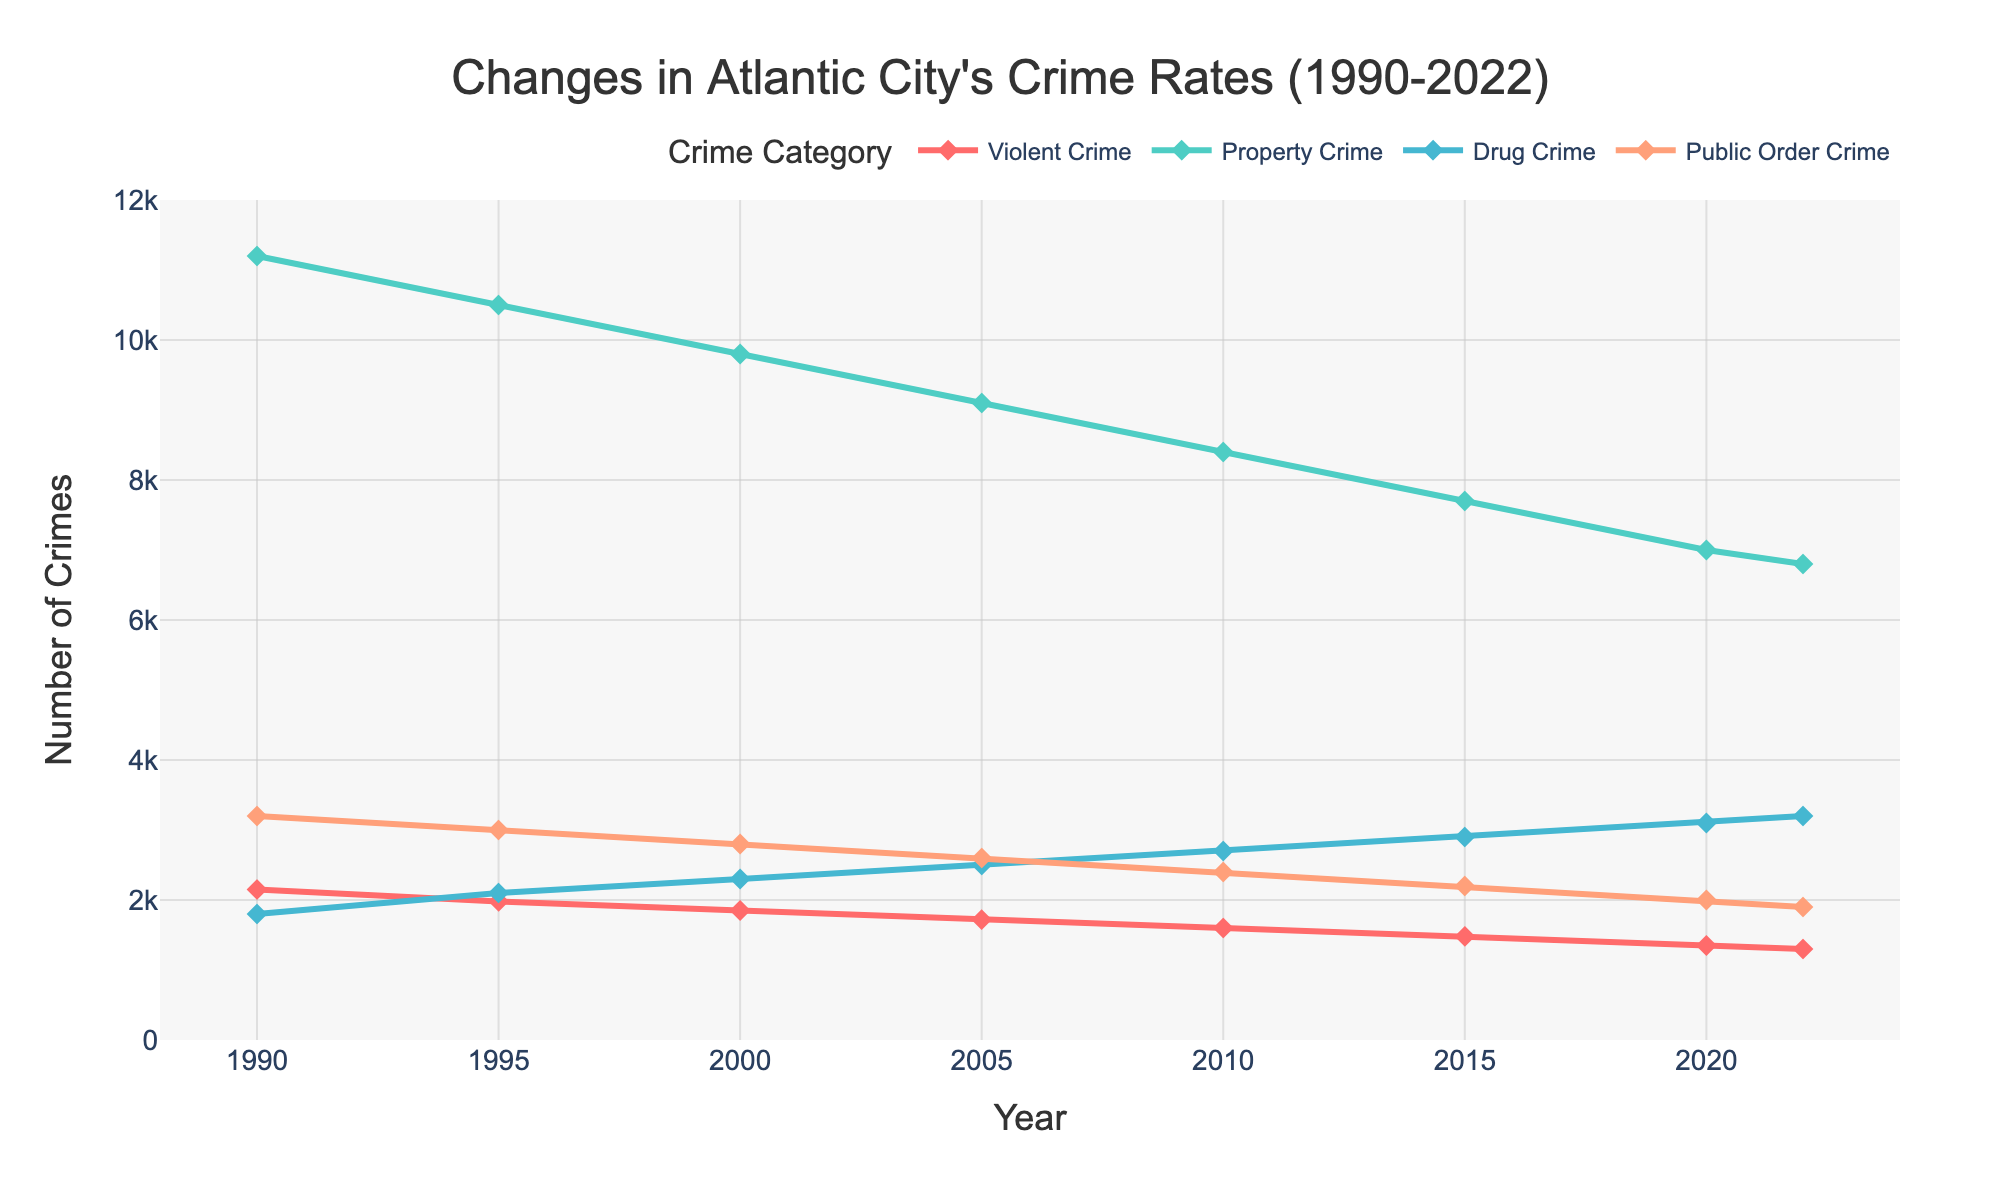How has the violent crime rate changed from 1990 to 2022? In 1990, the violent crime rate was 2150. By 2022, it decreased to 1300. The difference between these two values is 2150 - 1300 = 850, indicating a decrease in violent crime rate.
Answer: The violent crime rate decreased by 850 Which crime category had the largest reduction from 1990 to 2022? To determine the largest reduction, we subtract the crime rates in 2022 from those in 1990 for each category. Violent Crime: 2150 - 1300 = 850. Property Crime: 11200 - 6800 = 4400. Drug Crime: 1800 - 3200 = -1400 (an increase). Public Order Crime: 3200 - 1900 = 1300. Property Crime has the largest reduction: 4400.
Answer: Property Crime Comparing 1995 and 2022, which crime category saw the greatest decrease in absolute terms? Subtract 1995 figures from 2022 for each category. Violent Crime: 1980 - 1300 = 680. Property Crime: 10500 - 6800 = 3700. Drug Crime: 2100 - 3200 = -1100 (an increase). Public Order Crime: 3000 - 1900 = 1100. The greatest decrease is in Property Crime: 3700.
Answer: Property Crime In which year did Drug Crime surpass Public Order Crime for the first time? By observing the plot, we can see that Drug Crime surpasses Public Order Crime between 2005 and 2010. For exactitude, verify that in 2005 the Drug Crimes were 2500 and Public Order Crimes were 2600; in 2010, Drug Crimes were 2700 and Public Order Crimes were 2400. Thus, Drug Crime surpassed Public Order Crime in 2010.
Answer: 2010 Which crime category consistently declined from 1990 to 2022? By visually inspecting the plot lines, both Violent Crime and Property Crime show a consistent decline from 1990 to 2022. However, Violent Crime shows a more steady and consistent decline over the entire period.
Answer: Violent Crime What was the average number of Property Crimes between 2000 and 2010? Add the number of Property Crimes for the years 2000, 2005, and 2010 and then divide by 3. (9800 + 9100 + 8400) / 3 = 27300 / 3 = 9100.
Answer: 9100 Are there any years where the number of Public Order Crimes remains equal? By checking the figures, Public Order Crime remained constant at 3000 between the years 1995 and 2000; at 2600 between 2000 and 2005. There are no completely equal figures between any two separate years.
Answer: No Which three years show the steepest decline in Property Crime? Observing the plot for significant drops, 1990-1995 (11200-10500 = 700), 2005-2010 (9100- 8400 = 700), 2010-2015 (8400- 7700 = 700). By these calculations, three periods with notable declines are 1990-1995, 2005-2010, and 2010-2015.
Answer: 1990-1995, 2005-2010, 2010-2015 